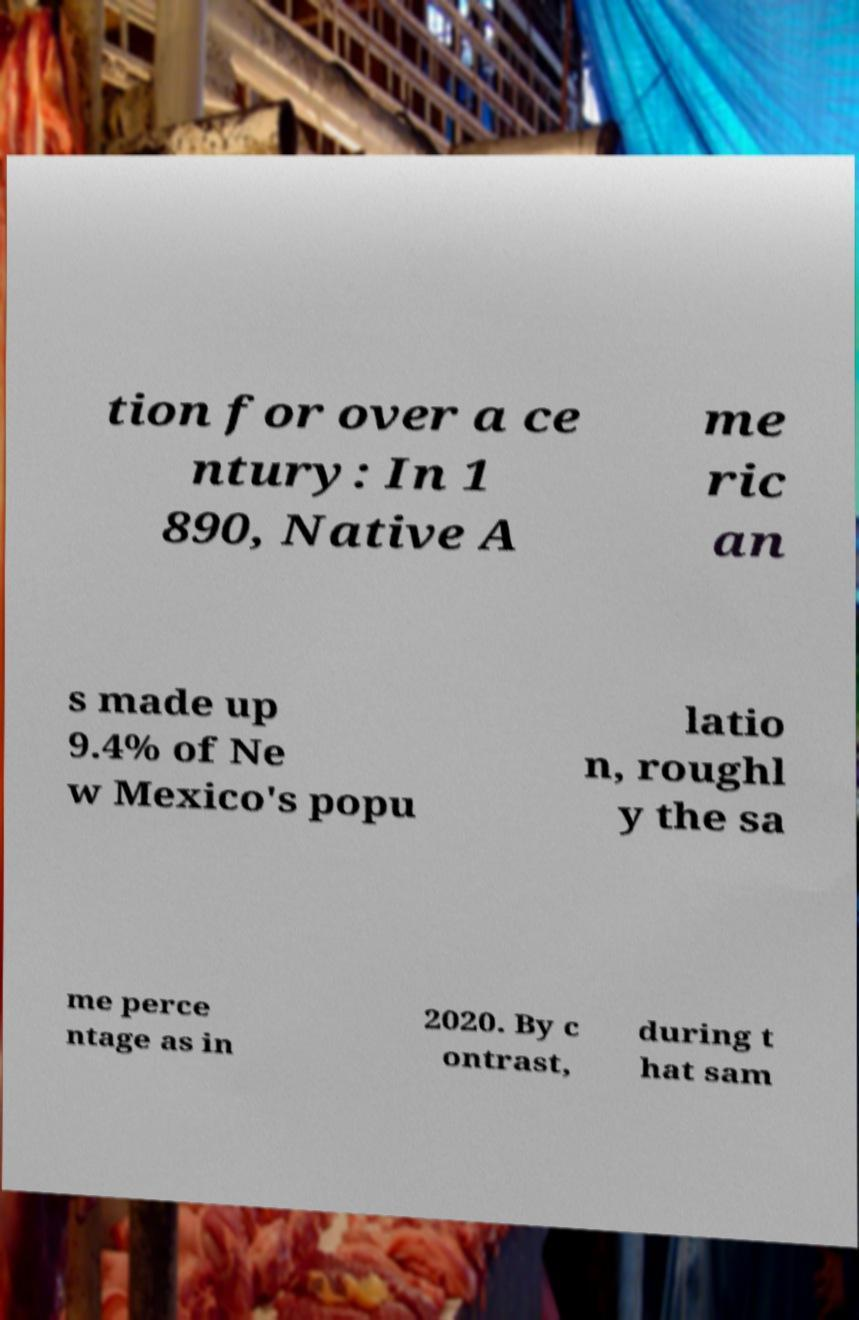There's text embedded in this image that I need extracted. Can you transcribe it verbatim? tion for over a ce ntury: In 1 890, Native A me ric an s made up 9.4% of Ne w Mexico's popu latio n, roughl y the sa me perce ntage as in 2020. By c ontrast, during t hat sam 